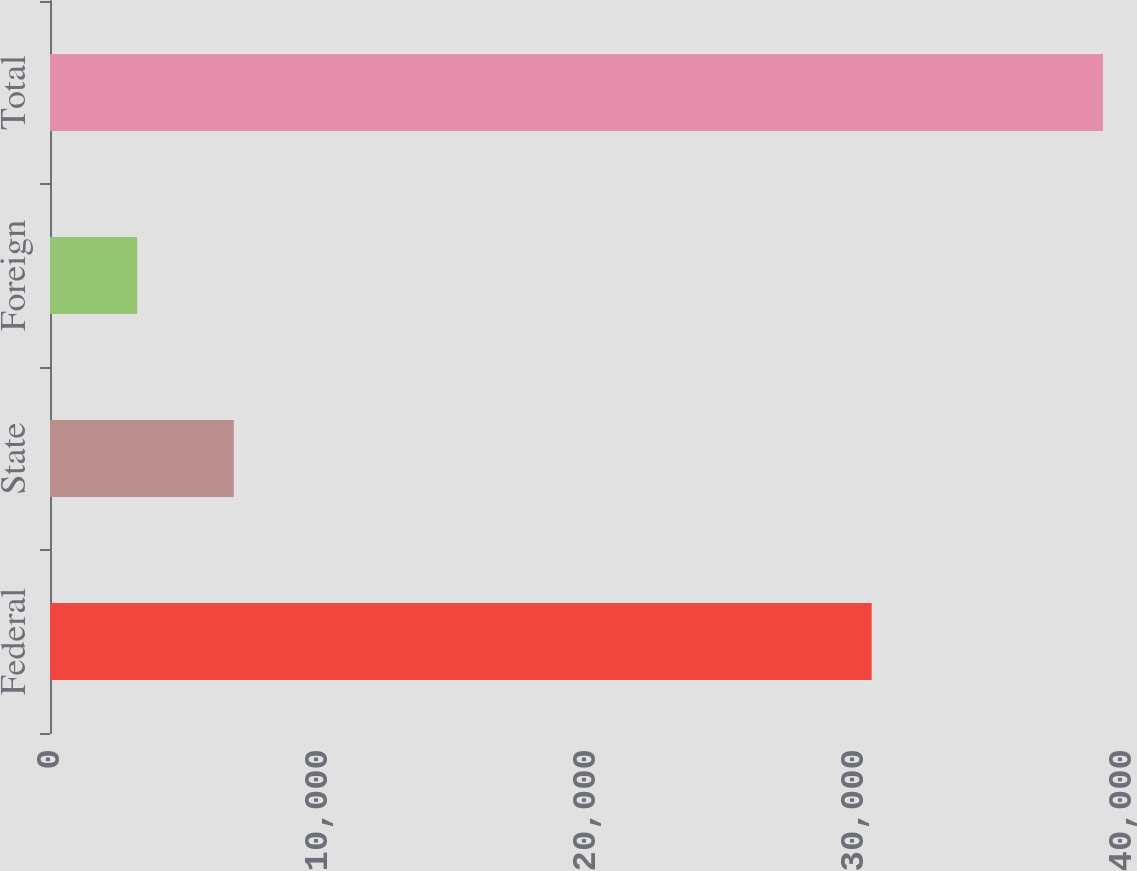Convert chart. <chart><loc_0><loc_0><loc_500><loc_500><bar_chart><fcel>Federal<fcel>State<fcel>Foreign<fcel>Total<nl><fcel>30660<fcel>6857.4<fcel>3254<fcel>39288<nl></chart> 